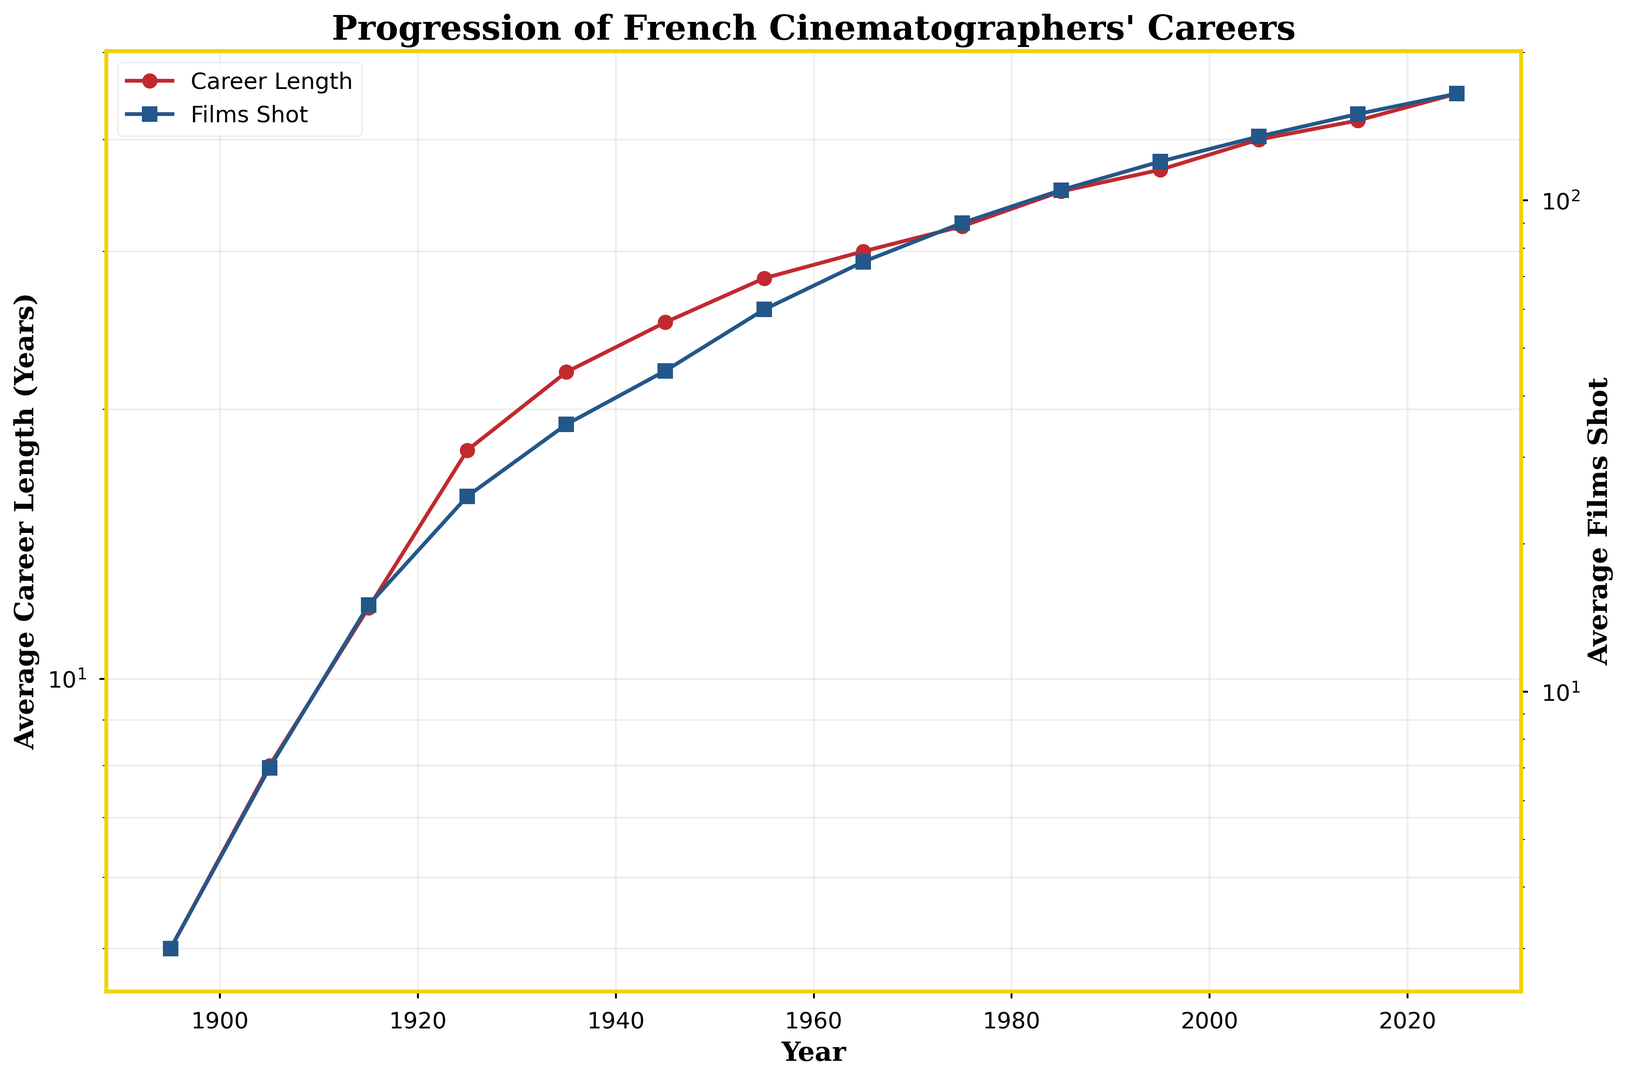What's the general trend in the average career length of French cinematographers from 1895 to 2025? The average career length generally increases over time. From 1895 to 2025, it goes from 5 years to 45 years, showing consistent growth.
Answer: Increasing How many more films were shot annually on average in 2025 compared to 1935? In 2025, the average number of films shot was 165, whereas in 1935 it was 35. The difference is 165 - 35 = 130.
Answer: 130 At what point does the average number of films shot reach 100? According to the plot, around 1985, the average number of films shot by French cinematographers reaches 105, which is the nearest value above 100.
Answer: 1985 Which period saw the most significant increase in career length for French cinematographers? The period from 1915 to 1925 saw a significant increase in average career length from 12 years to 18 years, an increase of 6 years. This is one of the substantial jumps in the dataset.
Answer: 1915 to 1925 Compare the trends of average career length and average films shot between 1965 and 2025. Both metrics show an increasing trend. The average career length increases from 30 years in 1965 to 45 years in 2025. The average number of films shot increases from 75 in 1965 to 165 in 2025. Both values roughly double over this period.
Answer: Both increased In which year were the average career length and the average number of films shot closest in value? In 1895, the average career length was 5 years and the average number of films shot was 3, making them the closest in value throughout the timeline.
Answer: 1895 What is the average increase in the number of films shot every decade from 1945 to 2025? The number of films shot increases from 45 in 1945 to 165 in 2025. Over 8 decades, this is an increase of 165 - 45 = 120 films. The average increase per decade is 120 / 8 = 15 films.
Answer: 15 films per decade How does the career length in 2015 compare to that in 1955? In 1955, the average career length was 28 years, whereas in 2015 it was 42 years. The career length in 2015 was 42 - 28 = 14 years longer.
Answer: 14 years longer What visual element distinguishes the line for average career length from the line for average films shot? The line for average career length is marked with circles and is red, whereas the line for average films shot is marked with squares and is blue.
Answer: Markers and colors 